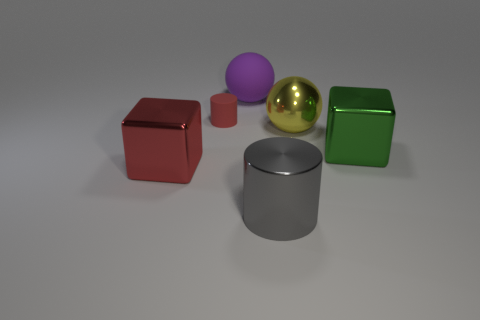Add 1 gray matte cubes. How many objects exist? 7 Subtract 1 green blocks. How many objects are left? 5 Subtract all balls. How many objects are left? 4 Subtract 1 cylinders. How many cylinders are left? 1 Subtract all cyan spheres. Subtract all cyan cylinders. How many spheres are left? 2 Subtract all purple balls. How many red cylinders are left? 1 Subtract all purple things. Subtract all large metallic cubes. How many objects are left? 3 Add 2 red objects. How many red objects are left? 4 Add 5 yellow metallic spheres. How many yellow metallic spheres exist? 6 